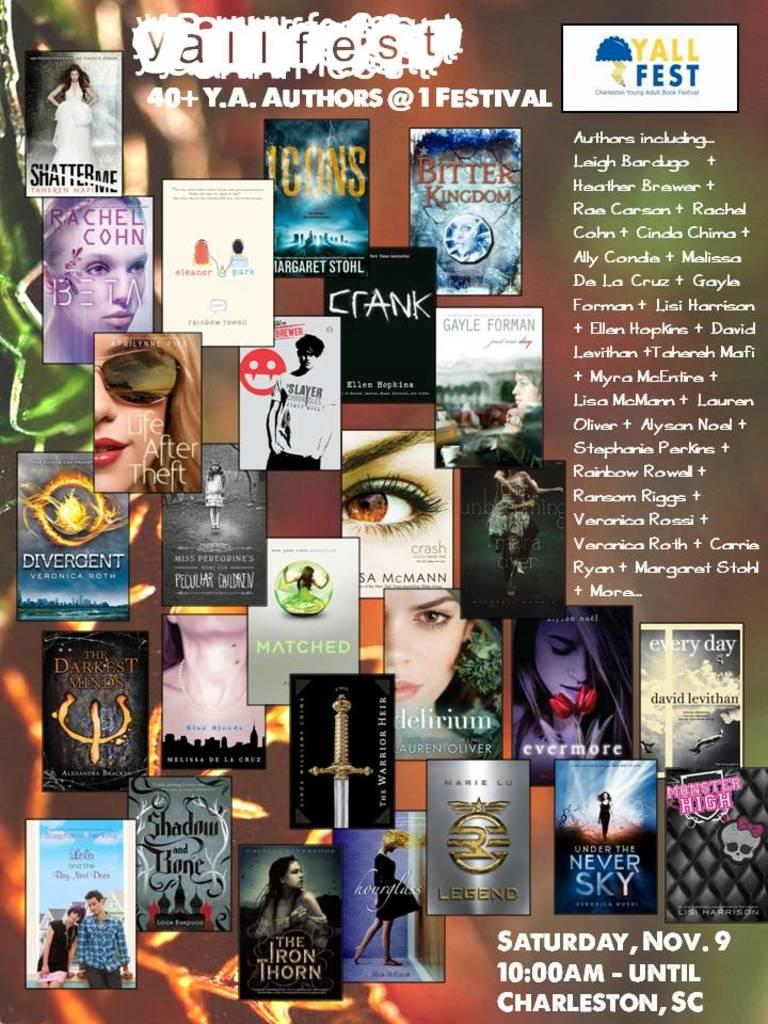<image>
Write a terse but informative summary of the picture. A poster featuring young adult authors advertises Yallfest. 